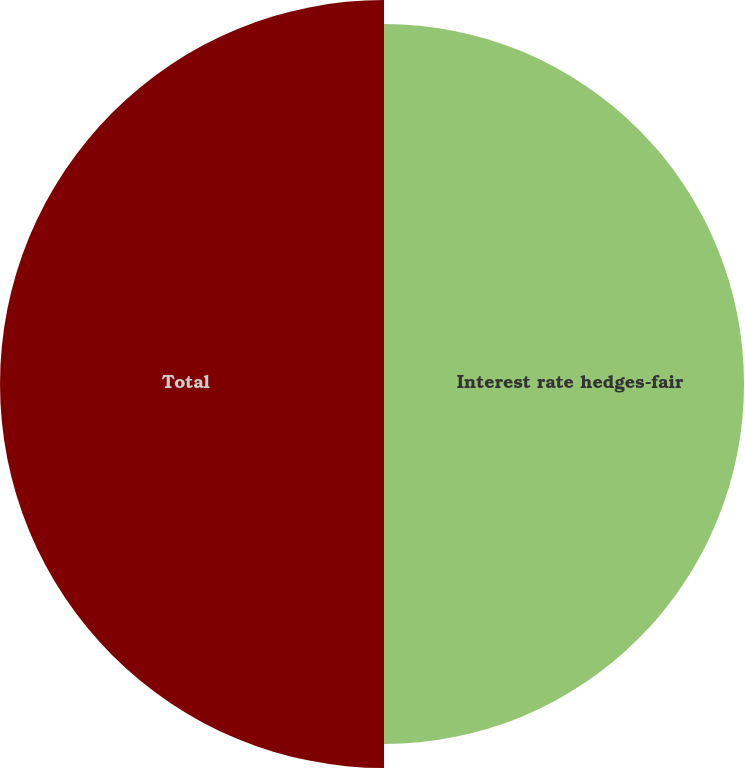Convert chart to OTSL. <chart><loc_0><loc_0><loc_500><loc_500><pie_chart><fcel>Interest rate hedges-fair<fcel>Total<nl><fcel>48.39%<fcel>51.61%<nl></chart> 